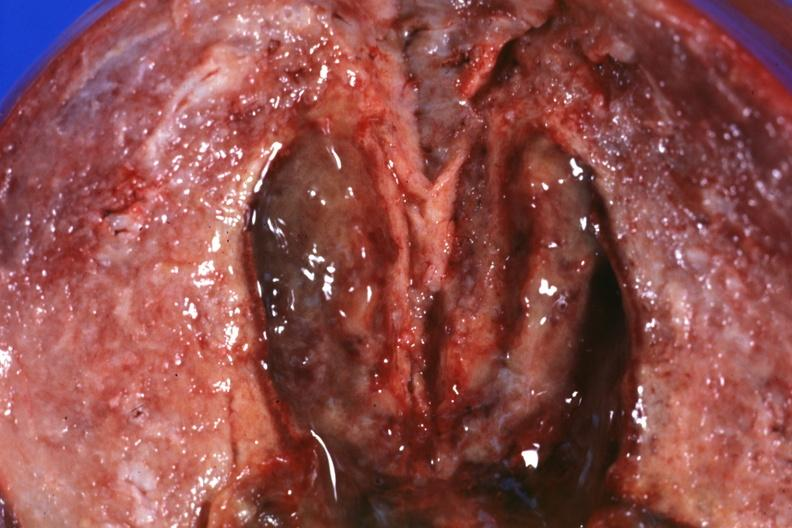what is present?
Answer the question using a single word or phrase. Uterus 